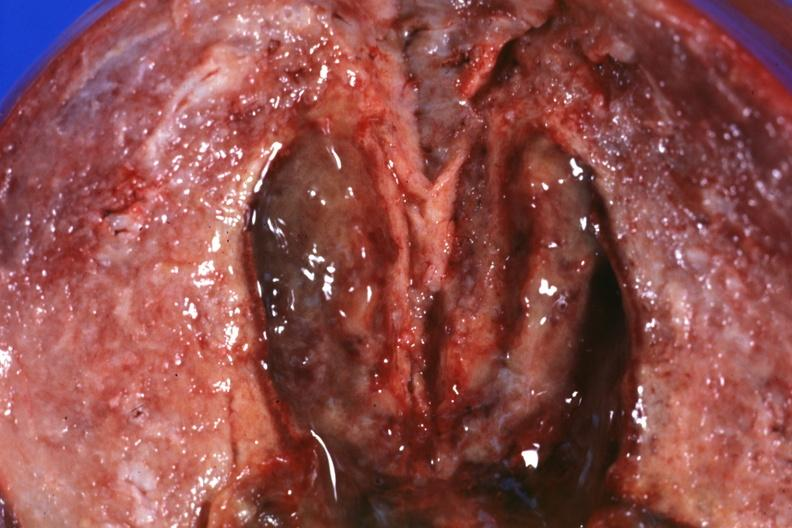what is present?
Answer the question using a single word or phrase. Uterus 